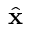Convert formula to latex. <formula><loc_0><loc_0><loc_500><loc_500>\hat { x }</formula> 